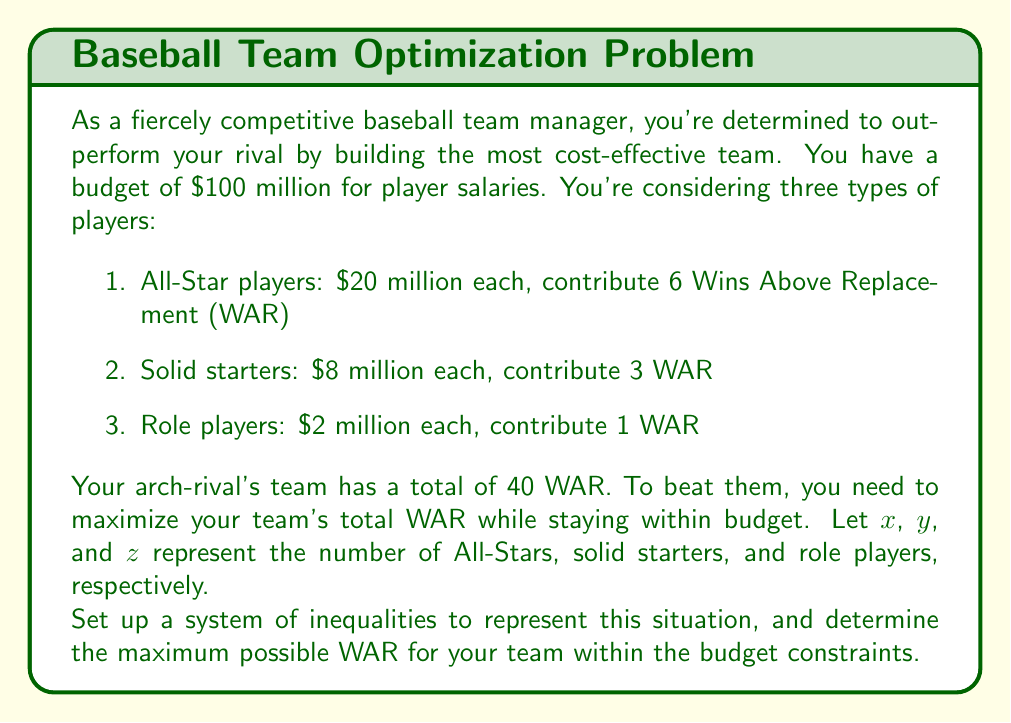Can you solve this math problem? Let's approach this step-by-step:

1) First, let's set up our inequalities:

   Budget constraint: $20x + 8y + 2z \leq 100$ (in millions)
   Non-negativity: $x \geq 0$, $y \geq 0$, $z \geq 0$
   Integer constraint: $x$, $y$, and $z$ must be integers

2) Our objective is to maximize the total WAR:

   $\text{Total WAR} = 6x + 3y + z$

3) We need to find the maximum value of this expression subject to our constraints.

4) This is an integer programming problem, which can be complex to solve analytically. However, we can use a systematic approach to find the optimal solution.

5) Let's start by maximizing the number of All-Stars (x), as they provide the most WAR per player:

   $20x \leq 100$
   $x \leq 5$

   So we can have at most 5 All-Stars, which would cost $100 million and provide 30 WAR.

6) However, this leaves no room for other players. Let's try 4 All-Stars:

   4 All-Stars cost $80 million, leaving $20 million.
   We can then add 2 solid starters for $16 million, leaving $4 million.
   Finally, we can add 2 role players for $4 million.

7) This gives us:
   4 All-Stars (24 WAR)
   2 Solid Starters (6 WAR)
   2 Role Players (2 WAR)

   Total: 32 WAR

8) We can verify that no other combination within the budget constraints gives a higher total WAR.
Answer: The maximum possible WAR for the team within the budget constraints is 32, achieved with 4 All-Stars, 2 Solid Starters, and 2 Role Players. 